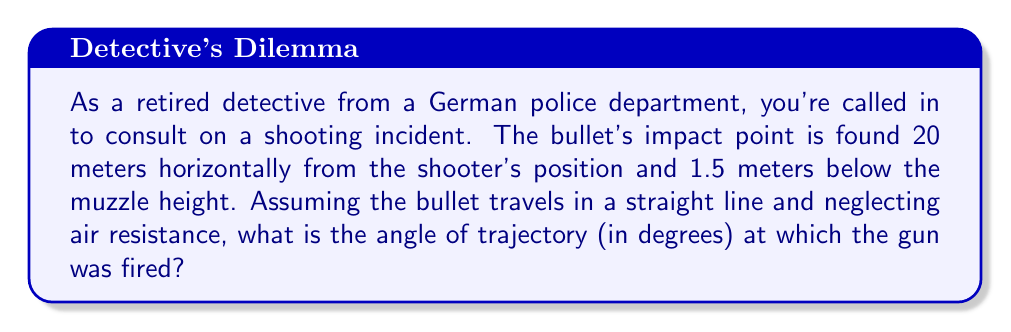Provide a solution to this math problem. To solve this problem, we need to use basic trigonometry. Let's approach this step-by-step:

1) First, let's visualize the scenario:

[asy]
import geometry;

unitsize(10mm);

pair A = (0,0);
pair B = (20,-1.5);

draw(A--B,arrow=Arrow(TeXHead));
draw(A--(20,0),dashed);
draw((20,-1.5)--(20,0),dashed);

label("Shooter", A, W);
label("Impact", B, E);
label("20 m", (10,0), N);
label("1.5 m", (20,-0.75), E);
label("$\theta$", (1,0), NW);

dot(A);
dot(B);
[/asy]

2) We can treat this as a right triangle, where:
   - The horizontal distance is the adjacent side (20 meters)
   - The vertical drop is the opposite side (1.5 meters)
   - The angle we're looking for is the angle between the trajectory and the horizontal

3) In this case, we need to find the angle $\theta$ using the arctangent function:

   $$\theta = \arctan(\frac{\text{opposite}}{\text{adjacent}})$$

4) Substituting our values:

   $$\theta = \arctan(\frac{1.5}{20})$$

5) Calculate:
   $$\theta = \arctan(0.075)$$

6) Convert to degrees:
   $$\theta \approx 4.29^\circ$$
Answer: The angle of trajectory is approximately $4.29^\circ$. 